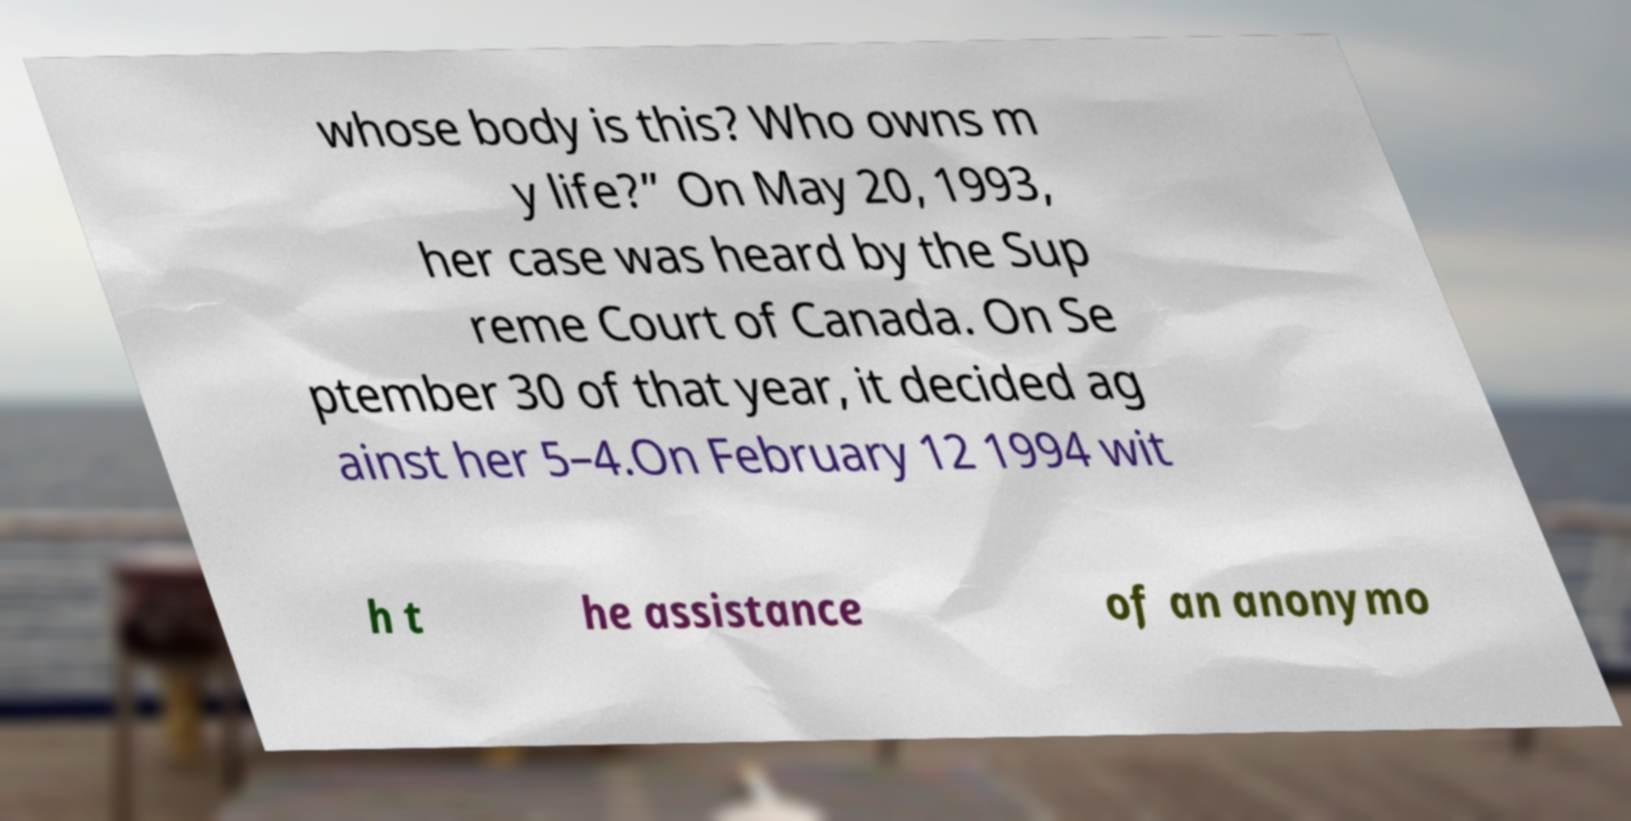Can you accurately transcribe the text from the provided image for me? whose body is this? Who owns m y life?” On May 20, 1993, her case was heard by the Sup reme Court of Canada. On Se ptember 30 of that year, it decided ag ainst her 5–4.On February 12 1994 wit h t he assistance of an anonymo 